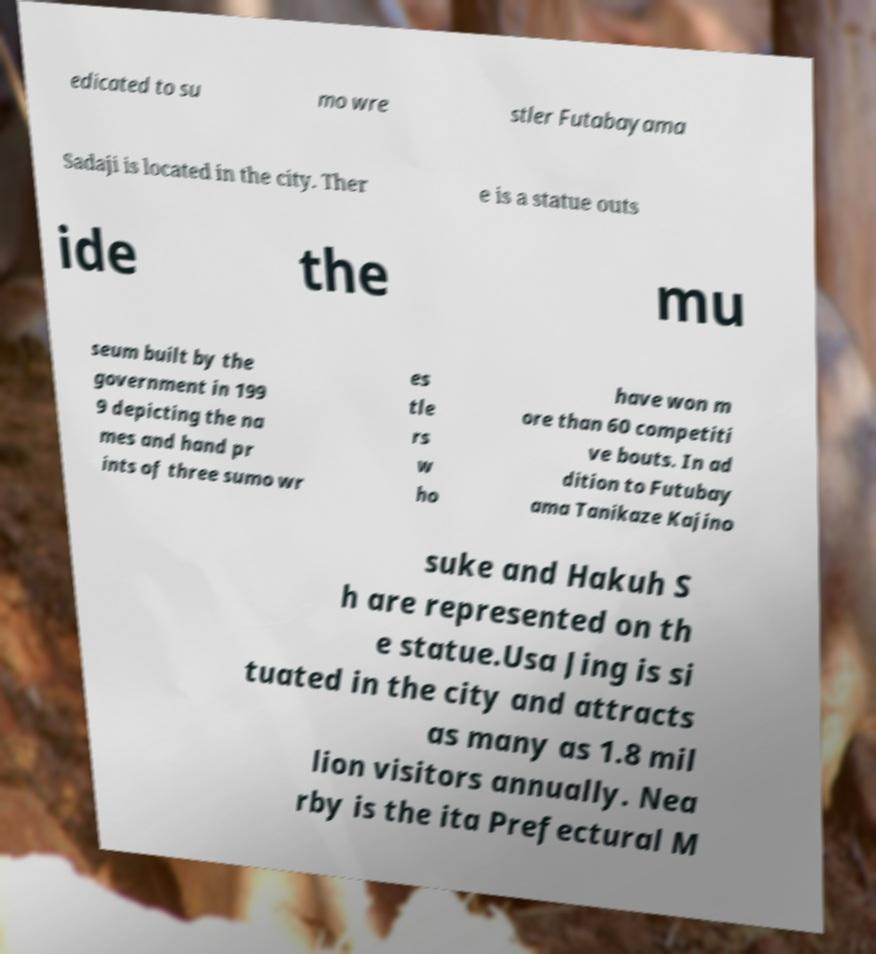Please read and relay the text visible in this image. What does it say? edicated to su mo wre stler Futabayama Sadaji is located in the city. Ther e is a statue outs ide the mu seum built by the government in 199 9 depicting the na mes and hand pr ints of three sumo wr es tle rs w ho have won m ore than 60 competiti ve bouts. In ad dition to Futubay ama Tanikaze Kajino suke and Hakuh S h are represented on th e statue.Usa Jing is si tuated in the city and attracts as many as 1.8 mil lion visitors annually. Nea rby is the ita Prefectural M 